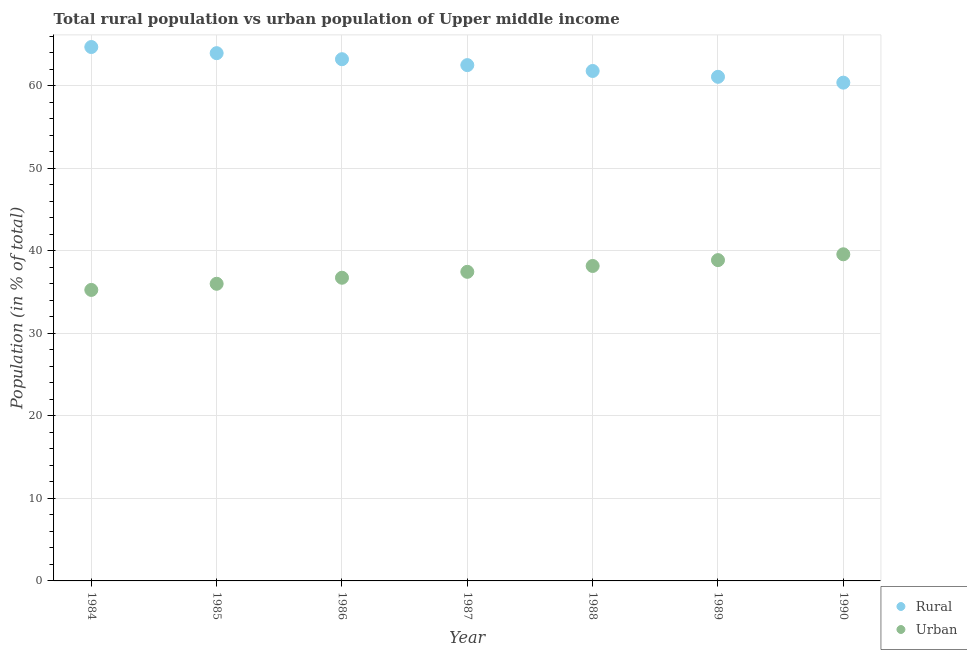Is the number of dotlines equal to the number of legend labels?
Your answer should be very brief. Yes. What is the rural population in 1987?
Offer a terse response. 62.53. Across all years, what is the maximum urban population?
Offer a very short reply. 39.6. Across all years, what is the minimum urban population?
Offer a very short reply. 35.28. In which year was the urban population maximum?
Your response must be concise. 1990. What is the total rural population in the graph?
Give a very brief answer. 437.81. What is the difference between the rural population in 1985 and that in 1989?
Make the answer very short. 2.87. What is the difference between the rural population in 1990 and the urban population in 1984?
Your answer should be very brief. 25.13. What is the average rural population per year?
Your answer should be very brief. 62.54. In the year 1987, what is the difference between the rural population and urban population?
Keep it short and to the point. 25.06. What is the ratio of the urban population in 1987 to that in 1989?
Keep it short and to the point. 0.96. Is the difference between the urban population in 1985 and 1986 greater than the difference between the rural population in 1985 and 1986?
Your answer should be compact. No. What is the difference between the highest and the second highest urban population?
Keep it short and to the point. 0.71. What is the difference between the highest and the lowest urban population?
Provide a short and direct response. 4.32. In how many years, is the urban population greater than the average urban population taken over all years?
Your response must be concise. 4. Is the sum of the urban population in 1985 and 1989 greater than the maximum rural population across all years?
Your answer should be very brief. Yes. Is the rural population strictly less than the urban population over the years?
Offer a terse response. No. How many years are there in the graph?
Offer a terse response. 7. How are the legend labels stacked?
Offer a very short reply. Vertical. What is the title of the graph?
Give a very brief answer. Total rural population vs urban population of Upper middle income. What is the label or title of the Y-axis?
Your answer should be compact. Population (in % of total). What is the Population (in % of total) of Rural in 1984?
Make the answer very short. 64.72. What is the Population (in % of total) of Urban in 1984?
Offer a very short reply. 35.28. What is the Population (in % of total) of Rural in 1985?
Offer a very short reply. 63.98. What is the Population (in % of total) in Urban in 1985?
Your answer should be very brief. 36.02. What is the Population (in % of total) in Rural in 1986?
Ensure brevity in your answer.  63.25. What is the Population (in % of total) of Urban in 1986?
Your answer should be very brief. 36.75. What is the Population (in % of total) in Rural in 1987?
Make the answer very short. 62.53. What is the Population (in % of total) in Urban in 1987?
Make the answer very short. 37.47. What is the Population (in % of total) in Rural in 1988?
Ensure brevity in your answer.  61.82. What is the Population (in % of total) of Urban in 1988?
Your answer should be compact. 38.18. What is the Population (in % of total) in Rural in 1989?
Offer a terse response. 61.11. What is the Population (in % of total) in Urban in 1989?
Make the answer very short. 38.89. What is the Population (in % of total) of Rural in 1990?
Your answer should be very brief. 60.4. What is the Population (in % of total) of Urban in 1990?
Offer a very short reply. 39.6. Across all years, what is the maximum Population (in % of total) in Rural?
Offer a very short reply. 64.72. Across all years, what is the maximum Population (in % of total) of Urban?
Ensure brevity in your answer.  39.6. Across all years, what is the minimum Population (in % of total) of Rural?
Your response must be concise. 60.4. Across all years, what is the minimum Population (in % of total) of Urban?
Keep it short and to the point. 35.28. What is the total Population (in % of total) in Rural in the graph?
Give a very brief answer. 437.81. What is the total Population (in % of total) in Urban in the graph?
Ensure brevity in your answer.  262.19. What is the difference between the Population (in % of total) in Rural in 1984 and that in 1985?
Offer a terse response. 0.74. What is the difference between the Population (in % of total) of Urban in 1984 and that in 1985?
Your answer should be compact. -0.74. What is the difference between the Population (in % of total) in Rural in 1984 and that in 1986?
Ensure brevity in your answer.  1.48. What is the difference between the Population (in % of total) of Urban in 1984 and that in 1986?
Your response must be concise. -1.48. What is the difference between the Population (in % of total) in Rural in 1984 and that in 1987?
Provide a succinct answer. 2.19. What is the difference between the Population (in % of total) of Urban in 1984 and that in 1987?
Make the answer very short. -2.19. What is the difference between the Population (in % of total) of Rural in 1984 and that in 1988?
Provide a succinct answer. 2.9. What is the difference between the Population (in % of total) in Urban in 1984 and that in 1988?
Offer a terse response. -2.9. What is the difference between the Population (in % of total) in Rural in 1984 and that in 1989?
Give a very brief answer. 3.61. What is the difference between the Population (in % of total) of Urban in 1984 and that in 1989?
Give a very brief answer. -3.61. What is the difference between the Population (in % of total) of Rural in 1984 and that in 1990?
Make the answer very short. 4.32. What is the difference between the Population (in % of total) of Urban in 1984 and that in 1990?
Keep it short and to the point. -4.32. What is the difference between the Population (in % of total) in Rural in 1985 and that in 1986?
Offer a very short reply. 0.73. What is the difference between the Population (in % of total) in Urban in 1985 and that in 1986?
Provide a short and direct response. -0.73. What is the difference between the Population (in % of total) of Rural in 1985 and that in 1987?
Keep it short and to the point. 1.45. What is the difference between the Population (in % of total) in Urban in 1985 and that in 1987?
Make the answer very short. -1.45. What is the difference between the Population (in % of total) in Rural in 1985 and that in 1988?
Offer a very short reply. 2.16. What is the difference between the Population (in % of total) in Urban in 1985 and that in 1988?
Ensure brevity in your answer.  -2.16. What is the difference between the Population (in % of total) in Rural in 1985 and that in 1989?
Offer a very short reply. 2.87. What is the difference between the Population (in % of total) of Urban in 1985 and that in 1989?
Make the answer very short. -2.87. What is the difference between the Population (in % of total) of Rural in 1985 and that in 1990?
Ensure brevity in your answer.  3.58. What is the difference between the Population (in % of total) of Urban in 1985 and that in 1990?
Your answer should be very brief. -3.58. What is the difference between the Population (in % of total) in Rural in 1986 and that in 1987?
Ensure brevity in your answer.  0.72. What is the difference between the Population (in % of total) of Urban in 1986 and that in 1987?
Your answer should be very brief. -0.72. What is the difference between the Population (in % of total) of Rural in 1986 and that in 1988?
Offer a terse response. 1.43. What is the difference between the Population (in % of total) of Urban in 1986 and that in 1988?
Your answer should be compact. -1.43. What is the difference between the Population (in % of total) of Rural in 1986 and that in 1989?
Offer a terse response. 2.14. What is the difference between the Population (in % of total) in Urban in 1986 and that in 1989?
Provide a short and direct response. -2.14. What is the difference between the Population (in % of total) of Rural in 1986 and that in 1990?
Provide a succinct answer. 2.84. What is the difference between the Population (in % of total) of Urban in 1986 and that in 1990?
Offer a terse response. -2.84. What is the difference between the Population (in % of total) in Rural in 1987 and that in 1988?
Your answer should be compact. 0.71. What is the difference between the Population (in % of total) in Urban in 1987 and that in 1988?
Your response must be concise. -0.71. What is the difference between the Population (in % of total) in Rural in 1987 and that in 1989?
Your answer should be compact. 1.42. What is the difference between the Population (in % of total) of Urban in 1987 and that in 1989?
Provide a succinct answer. -1.42. What is the difference between the Population (in % of total) in Rural in 1987 and that in 1990?
Give a very brief answer. 2.13. What is the difference between the Population (in % of total) in Urban in 1987 and that in 1990?
Your response must be concise. -2.13. What is the difference between the Population (in % of total) of Rural in 1988 and that in 1989?
Provide a succinct answer. 0.71. What is the difference between the Population (in % of total) in Urban in 1988 and that in 1989?
Give a very brief answer. -0.71. What is the difference between the Population (in % of total) in Rural in 1988 and that in 1990?
Provide a succinct answer. 1.42. What is the difference between the Population (in % of total) of Urban in 1988 and that in 1990?
Offer a terse response. -1.42. What is the difference between the Population (in % of total) in Rural in 1989 and that in 1990?
Your response must be concise. 0.71. What is the difference between the Population (in % of total) in Urban in 1989 and that in 1990?
Offer a terse response. -0.71. What is the difference between the Population (in % of total) in Rural in 1984 and the Population (in % of total) in Urban in 1985?
Keep it short and to the point. 28.7. What is the difference between the Population (in % of total) in Rural in 1984 and the Population (in % of total) in Urban in 1986?
Offer a terse response. 27.97. What is the difference between the Population (in % of total) in Rural in 1984 and the Population (in % of total) in Urban in 1987?
Your answer should be very brief. 27.25. What is the difference between the Population (in % of total) in Rural in 1984 and the Population (in % of total) in Urban in 1988?
Provide a succinct answer. 26.54. What is the difference between the Population (in % of total) in Rural in 1984 and the Population (in % of total) in Urban in 1989?
Your answer should be very brief. 25.83. What is the difference between the Population (in % of total) in Rural in 1984 and the Population (in % of total) in Urban in 1990?
Your response must be concise. 25.13. What is the difference between the Population (in % of total) in Rural in 1985 and the Population (in % of total) in Urban in 1986?
Your answer should be very brief. 27.22. What is the difference between the Population (in % of total) of Rural in 1985 and the Population (in % of total) of Urban in 1987?
Keep it short and to the point. 26.51. What is the difference between the Population (in % of total) of Rural in 1985 and the Population (in % of total) of Urban in 1988?
Give a very brief answer. 25.8. What is the difference between the Population (in % of total) in Rural in 1985 and the Population (in % of total) in Urban in 1989?
Ensure brevity in your answer.  25.09. What is the difference between the Population (in % of total) of Rural in 1985 and the Population (in % of total) of Urban in 1990?
Give a very brief answer. 24.38. What is the difference between the Population (in % of total) of Rural in 1986 and the Population (in % of total) of Urban in 1987?
Provide a succinct answer. 25.78. What is the difference between the Population (in % of total) of Rural in 1986 and the Population (in % of total) of Urban in 1988?
Provide a short and direct response. 25.07. What is the difference between the Population (in % of total) in Rural in 1986 and the Population (in % of total) in Urban in 1989?
Ensure brevity in your answer.  24.36. What is the difference between the Population (in % of total) of Rural in 1986 and the Population (in % of total) of Urban in 1990?
Your response must be concise. 23.65. What is the difference between the Population (in % of total) of Rural in 1987 and the Population (in % of total) of Urban in 1988?
Offer a terse response. 24.35. What is the difference between the Population (in % of total) of Rural in 1987 and the Population (in % of total) of Urban in 1989?
Provide a short and direct response. 23.64. What is the difference between the Population (in % of total) in Rural in 1987 and the Population (in % of total) in Urban in 1990?
Make the answer very short. 22.93. What is the difference between the Population (in % of total) in Rural in 1988 and the Population (in % of total) in Urban in 1989?
Your answer should be compact. 22.93. What is the difference between the Population (in % of total) of Rural in 1988 and the Population (in % of total) of Urban in 1990?
Your response must be concise. 22.22. What is the difference between the Population (in % of total) of Rural in 1989 and the Population (in % of total) of Urban in 1990?
Provide a succinct answer. 21.51. What is the average Population (in % of total) of Rural per year?
Your answer should be very brief. 62.54. What is the average Population (in % of total) in Urban per year?
Offer a terse response. 37.46. In the year 1984, what is the difference between the Population (in % of total) in Rural and Population (in % of total) in Urban?
Your answer should be very brief. 29.45. In the year 1985, what is the difference between the Population (in % of total) in Rural and Population (in % of total) in Urban?
Provide a succinct answer. 27.96. In the year 1986, what is the difference between the Population (in % of total) of Rural and Population (in % of total) of Urban?
Provide a succinct answer. 26.49. In the year 1987, what is the difference between the Population (in % of total) of Rural and Population (in % of total) of Urban?
Make the answer very short. 25.06. In the year 1988, what is the difference between the Population (in % of total) in Rural and Population (in % of total) in Urban?
Offer a very short reply. 23.64. In the year 1989, what is the difference between the Population (in % of total) of Rural and Population (in % of total) of Urban?
Your response must be concise. 22.22. In the year 1990, what is the difference between the Population (in % of total) in Rural and Population (in % of total) in Urban?
Offer a very short reply. 20.81. What is the ratio of the Population (in % of total) in Rural in 1984 to that in 1985?
Provide a short and direct response. 1.01. What is the ratio of the Population (in % of total) in Urban in 1984 to that in 1985?
Offer a terse response. 0.98. What is the ratio of the Population (in % of total) in Rural in 1984 to that in 1986?
Make the answer very short. 1.02. What is the ratio of the Population (in % of total) in Urban in 1984 to that in 1986?
Offer a very short reply. 0.96. What is the ratio of the Population (in % of total) of Rural in 1984 to that in 1987?
Provide a succinct answer. 1.04. What is the ratio of the Population (in % of total) in Urban in 1984 to that in 1987?
Offer a very short reply. 0.94. What is the ratio of the Population (in % of total) in Rural in 1984 to that in 1988?
Provide a short and direct response. 1.05. What is the ratio of the Population (in % of total) of Urban in 1984 to that in 1988?
Offer a very short reply. 0.92. What is the ratio of the Population (in % of total) in Rural in 1984 to that in 1989?
Ensure brevity in your answer.  1.06. What is the ratio of the Population (in % of total) in Urban in 1984 to that in 1989?
Your answer should be very brief. 0.91. What is the ratio of the Population (in % of total) in Rural in 1984 to that in 1990?
Ensure brevity in your answer.  1.07. What is the ratio of the Population (in % of total) in Urban in 1984 to that in 1990?
Make the answer very short. 0.89. What is the ratio of the Population (in % of total) of Rural in 1985 to that in 1986?
Your answer should be compact. 1.01. What is the ratio of the Population (in % of total) in Urban in 1985 to that in 1986?
Keep it short and to the point. 0.98. What is the ratio of the Population (in % of total) in Rural in 1985 to that in 1987?
Offer a terse response. 1.02. What is the ratio of the Population (in % of total) of Urban in 1985 to that in 1987?
Provide a short and direct response. 0.96. What is the ratio of the Population (in % of total) of Rural in 1985 to that in 1988?
Offer a terse response. 1.03. What is the ratio of the Population (in % of total) in Urban in 1985 to that in 1988?
Provide a succinct answer. 0.94. What is the ratio of the Population (in % of total) in Rural in 1985 to that in 1989?
Your answer should be very brief. 1.05. What is the ratio of the Population (in % of total) of Urban in 1985 to that in 1989?
Keep it short and to the point. 0.93. What is the ratio of the Population (in % of total) in Rural in 1985 to that in 1990?
Ensure brevity in your answer.  1.06. What is the ratio of the Population (in % of total) of Urban in 1985 to that in 1990?
Your answer should be very brief. 0.91. What is the ratio of the Population (in % of total) in Rural in 1986 to that in 1987?
Your answer should be very brief. 1.01. What is the ratio of the Population (in % of total) of Urban in 1986 to that in 1987?
Your answer should be very brief. 0.98. What is the ratio of the Population (in % of total) in Rural in 1986 to that in 1988?
Give a very brief answer. 1.02. What is the ratio of the Population (in % of total) of Urban in 1986 to that in 1988?
Make the answer very short. 0.96. What is the ratio of the Population (in % of total) in Rural in 1986 to that in 1989?
Offer a terse response. 1.03. What is the ratio of the Population (in % of total) in Urban in 1986 to that in 1989?
Your answer should be very brief. 0.95. What is the ratio of the Population (in % of total) in Rural in 1986 to that in 1990?
Provide a succinct answer. 1.05. What is the ratio of the Population (in % of total) in Urban in 1986 to that in 1990?
Your answer should be very brief. 0.93. What is the ratio of the Population (in % of total) of Rural in 1987 to that in 1988?
Keep it short and to the point. 1.01. What is the ratio of the Population (in % of total) of Urban in 1987 to that in 1988?
Provide a short and direct response. 0.98. What is the ratio of the Population (in % of total) of Rural in 1987 to that in 1989?
Offer a very short reply. 1.02. What is the ratio of the Population (in % of total) of Urban in 1987 to that in 1989?
Provide a succinct answer. 0.96. What is the ratio of the Population (in % of total) of Rural in 1987 to that in 1990?
Your answer should be compact. 1.04. What is the ratio of the Population (in % of total) in Urban in 1987 to that in 1990?
Give a very brief answer. 0.95. What is the ratio of the Population (in % of total) of Rural in 1988 to that in 1989?
Your answer should be very brief. 1.01. What is the ratio of the Population (in % of total) in Urban in 1988 to that in 1989?
Your response must be concise. 0.98. What is the ratio of the Population (in % of total) of Rural in 1988 to that in 1990?
Give a very brief answer. 1.02. What is the ratio of the Population (in % of total) in Urban in 1988 to that in 1990?
Offer a very short reply. 0.96. What is the ratio of the Population (in % of total) in Rural in 1989 to that in 1990?
Keep it short and to the point. 1.01. What is the ratio of the Population (in % of total) of Urban in 1989 to that in 1990?
Offer a very short reply. 0.98. What is the difference between the highest and the second highest Population (in % of total) of Rural?
Make the answer very short. 0.74. What is the difference between the highest and the second highest Population (in % of total) in Urban?
Give a very brief answer. 0.71. What is the difference between the highest and the lowest Population (in % of total) of Rural?
Your response must be concise. 4.32. What is the difference between the highest and the lowest Population (in % of total) in Urban?
Provide a short and direct response. 4.32. 